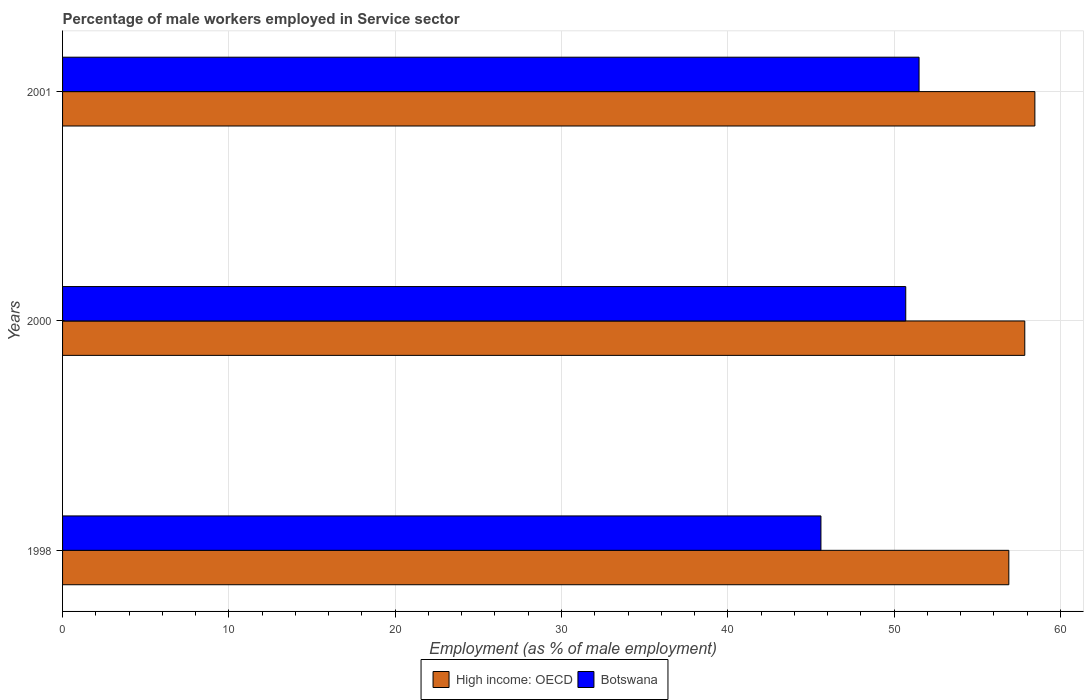How many groups of bars are there?
Offer a terse response. 3. How many bars are there on the 1st tick from the top?
Offer a terse response. 2. How many bars are there on the 1st tick from the bottom?
Provide a succinct answer. 2. What is the label of the 3rd group of bars from the top?
Your answer should be compact. 1998. What is the percentage of male workers employed in Service sector in Botswana in 2000?
Offer a terse response. 50.7. Across all years, what is the maximum percentage of male workers employed in Service sector in High income: OECD?
Ensure brevity in your answer.  58.46. Across all years, what is the minimum percentage of male workers employed in Service sector in Botswana?
Your response must be concise. 45.6. In which year was the percentage of male workers employed in Service sector in High income: OECD maximum?
Your answer should be compact. 2001. In which year was the percentage of male workers employed in Service sector in High income: OECD minimum?
Keep it short and to the point. 1998. What is the total percentage of male workers employed in Service sector in Botswana in the graph?
Provide a succinct answer. 147.8. What is the difference between the percentage of male workers employed in Service sector in Botswana in 1998 and that in 2000?
Provide a short and direct response. -5.1. What is the difference between the percentage of male workers employed in Service sector in Botswana in 2000 and the percentage of male workers employed in Service sector in High income: OECD in 1998?
Make the answer very short. -6.2. What is the average percentage of male workers employed in Service sector in Botswana per year?
Provide a succinct answer. 49.27. In the year 1998, what is the difference between the percentage of male workers employed in Service sector in Botswana and percentage of male workers employed in Service sector in High income: OECD?
Your answer should be very brief. -11.3. What is the ratio of the percentage of male workers employed in Service sector in Botswana in 2000 to that in 2001?
Give a very brief answer. 0.98. Is the percentage of male workers employed in Service sector in High income: OECD in 1998 less than that in 2001?
Give a very brief answer. Yes. Is the difference between the percentage of male workers employed in Service sector in Botswana in 1998 and 2001 greater than the difference between the percentage of male workers employed in Service sector in High income: OECD in 1998 and 2001?
Make the answer very short. No. What is the difference between the highest and the second highest percentage of male workers employed in Service sector in High income: OECD?
Keep it short and to the point. 0.61. What is the difference between the highest and the lowest percentage of male workers employed in Service sector in High income: OECD?
Give a very brief answer. 1.57. What does the 1st bar from the top in 2000 represents?
Give a very brief answer. Botswana. What does the 1st bar from the bottom in 1998 represents?
Offer a terse response. High income: OECD. How many bars are there?
Provide a short and direct response. 6. Are all the bars in the graph horizontal?
Provide a short and direct response. Yes. How many years are there in the graph?
Your response must be concise. 3. Does the graph contain grids?
Make the answer very short. Yes. How are the legend labels stacked?
Keep it short and to the point. Horizontal. What is the title of the graph?
Your response must be concise. Percentage of male workers employed in Service sector. Does "Vietnam" appear as one of the legend labels in the graph?
Offer a terse response. No. What is the label or title of the X-axis?
Offer a very short reply. Employment (as % of male employment). What is the label or title of the Y-axis?
Your response must be concise. Years. What is the Employment (as % of male employment) in High income: OECD in 1998?
Ensure brevity in your answer.  56.9. What is the Employment (as % of male employment) in Botswana in 1998?
Ensure brevity in your answer.  45.6. What is the Employment (as % of male employment) in High income: OECD in 2000?
Your response must be concise. 57.86. What is the Employment (as % of male employment) in Botswana in 2000?
Your answer should be very brief. 50.7. What is the Employment (as % of male employment) in High income: OECD in 2001?
Offer a terse response. 58.46. What is the Employment (as % of male employment) in Botswana in 2001?
Ensure brevity in your answer.  51.5. Across all years, what is the maximum Employment (as % of male employment) in High income: OECD?
Your response must be concise. 58.46. Across all years, what is the maximum Employment (as % of male employment) of Botswana?
Keep it short and to the point. 51.5. Across all years, what is the minimum Employment (as % of male employment) of High income: OECD?
Give a very brief answer. 56.9. Across all years, what is the minimum Employment (as % of male employment) of Botswana?
Keep it short and to the point. 45.6. What is the total Employment (as % of male employment) in High income: OECD in the graph?
Offer a terse response. 173.22. What is the total Employment (as % of male employment) of Botswana in the graph?
Provide a succinct answer. 147.8. What is the difference between the Employment (as % of male employment) in High income: OECD in 1998 and that in 2000?
Your answer should be compact. -0.96. What is the difference between the Employment (as % of male employment) of Botswana in 1998 and that in 2000?
Your answer should be very brief. -5.1. What is the difference between the Employment (as % of male employment) in High income: OECD in 1998 and that in 2001?
Provide a succinct answer. -1.57. What is the difference between the Employment (as % of male employment) of Botswana in 1998 and that in 2001?
Your answer should be compact. -5.9. What is the difference between the Employment (as % of male employment) in High income: OECD in 2000 and that in 2001?
Provide a succinct answer. -0.61. What is the difference between the Employment (as % of male employment) of Botswana in 2000 and that in 2001?
Provide a short and direct response. -0.8. What is the difference between the Employment (as % of male employment) of High income: OECD in 1998 and the Employment (as % of male employment) of Botswana in 2000?
Provide a succinct answer. 6.2. What is the difference between the Employment (as % of male employment) of High income: OECD in 1998 and the Employment (as % of male employment) of Botswana in 2001?
Provide a short and direct response. 5.4. What is the difference between the Employment (as % of male employment) of High income: OECD in 2000 and the Employment (as % of male employment) of Botswana in 2001?
Your answer should be compact. 6.36. What is the average Employment (as % of male employment) of High income: OECD per year?
Ensure brevity in your answer.  57.74. What is the average Employment (as % of male employment) in Botswana per year?
Offer a terse response. 49.27. In the year 1998, what is the difference between the Employment (as % of male employment) in High income: OECD and Employment (as % of male employment) in Botswana?
Your answer should be compact. 11.3. In the year 2000, what is the difference between the Employment (as % of male employment) of High income: OECD and Employment (as % of male employment) of Botswana?
Ensure brevity in your answer.  7.16. In the year 2001, what is the difference between the Employment (as % of male employment) of High income: OECD and Employment (as % of male employment) of Botswana?
Make the answer very short. 6.96. What is the ratio of the Employment (as % of male employment) in High income: OECD in 1998 to that in 2000?
Provide a short and direct response. 0.98. What is the ratio of the Employment (as % of male employment) of Botswana in 1998 to that in 2000?
Offer a very short reply. 0.9. What is the ratio of the Employment (as % of male employment) of High income: OECD in 1998 to that in 2001?
Your answer should be compact. 0.97. What is the ratio of the Employment (as % of male employment) in Botswana in 1998 to that in 2001?
Offer a very short reply. 0.89. What is the ratio of the Employment (as % of male employment) in Botswana in 2000 to that in 2001?
Ensure brevity in your answer.  0.98. What is the difference between the highest and the second highest Employment (as % of male employment) in High income: OECD?
Offer a very short reply. 0.61. What is the difference between the highest and the second highest Employment (as % of male employment) of Botswana?
Offer a terse response. 0.8. What is the difference between the highest and the lowest Employment (as % of male employment) of High income: OECD?
Provide a short and direct response. 1.57. What is the difference between the highest and the lowest Employment (as % of male employment) in Botswana?
Give a very brief answer. 5.9. 